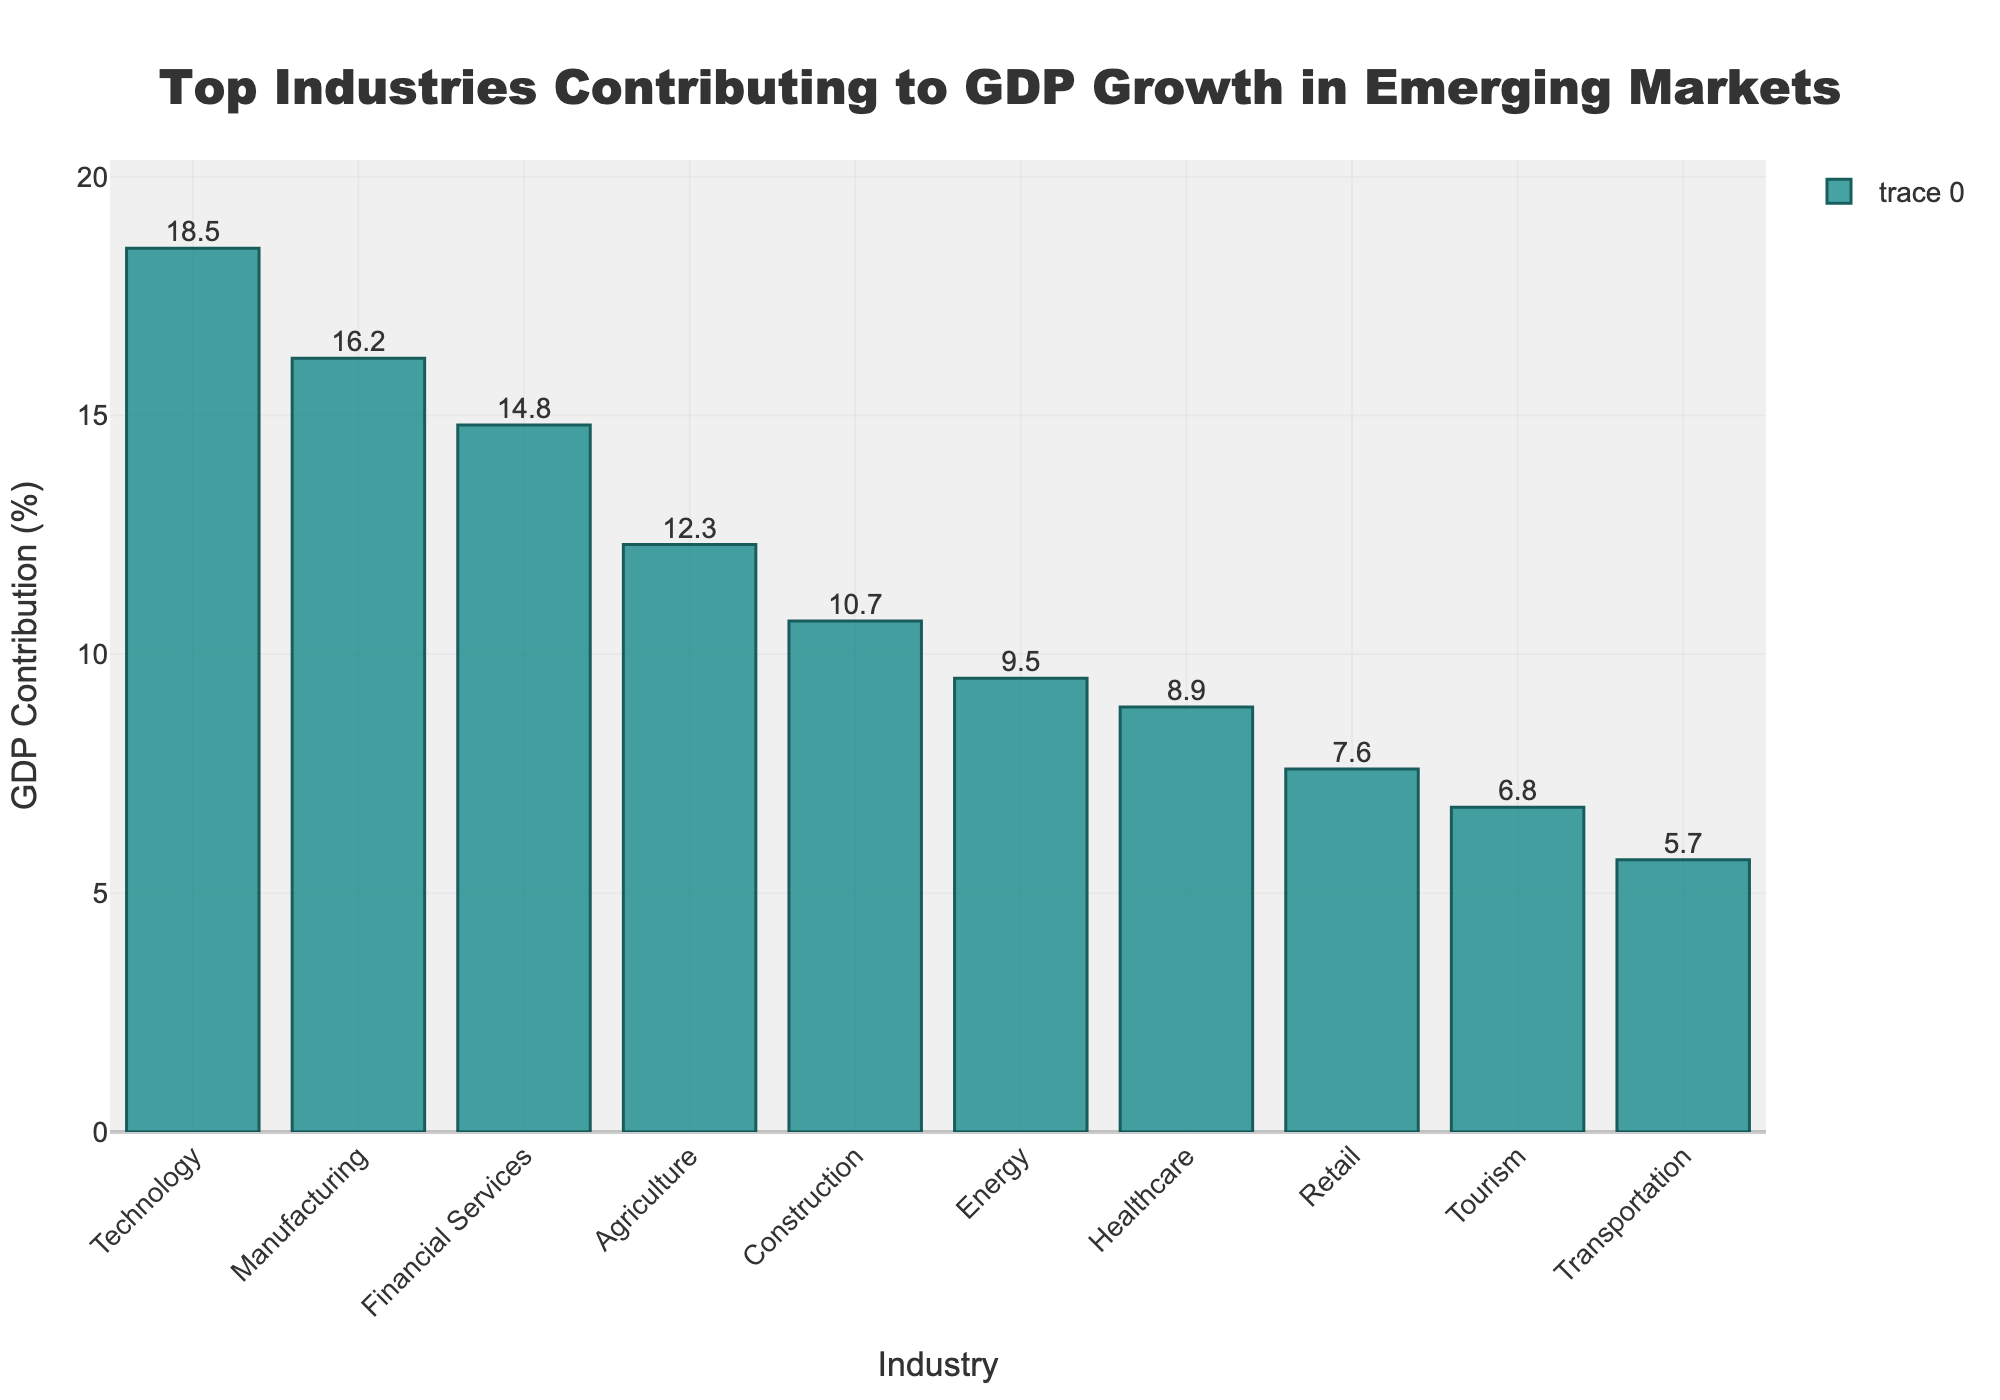Which industry has the highest contribution to the GDP? The bar chart indicates the contribution of various industries to GDP growth. The highest bar represents the industry with the largest contribution. Technology is shown as the highest bar.
Answer: Technology What is the combined GDP contribution percentage of the top three industries? Sum the GDP contribution percentages of the Technology, Manufacturing, and Financial Services industries shown on the chart. (18.5 + 16.2 + 14.8 = 49.5)
Answer: 49.5% How does the GDP contribution of Agriculture compare to Construction? By looking at the heights of the bars for Agriculture and Construction, we can see that Agriculture has a higher GDP contribution (12.3%) compared to Construction (10.7%).
Answer: Agriculture has a higher GDP contribution than Construction Which industry contributes less than 10% but more than 8% to GDP growth? By examining the bars that fall within the range of 8% to 10%, we find that Energy (9.5%) and Healthcare (8.9%) fit this criterion. However, only the Energy bar is less than 10% but more than 8%.
Answer: Energy What percentage does the Transportation industry contribute to the GDP growth, and is it the lowest among the top industries? By looking at the bar for Transportation, we see it at 5.7%. Scanning all the bars, this is indeed the lowest contribution among the top listed industries.
Answer: Transportation contributes 5.7% and is the lowest If the GDP contributions of Healthcare and Retail are combined, what's their total percentage? Adding the GDP contributions of Healthcare (8.9%) and Retail (7.6%) gives the combined total (8.9 + 7.6 = 16.5).
Answer: 16.5% Which industries have a GDP contribution above 15%? Analyzing the heights of the bars shows that Technology (18.5%) and Manufacturing (16.2%) have GDP contributions above 15%.
Answer: Technology and Manufacturing Compare the GDP contributions of the Financial Services and Construction industries. Which one is greater and by how much? Financial Services contribute 14.8% and Construction contributes 10.7%. Subtract Construction's contribution from Financial Services' (14.8 - 10.7 = 4.1). Financial Services contributes more by 4.1%.
Answer: Financial Services, 4.1% What is the difference in GDP contributions between Agriculture and Energy industries? Agriculture contributes 12.3% and Energy contributes 9.5%. Subtract Energy's contribution from Agriculture's (12.3 - 9.5 = 2.8). The difference in contribution is 2.8%.
Answer: 2.8% 